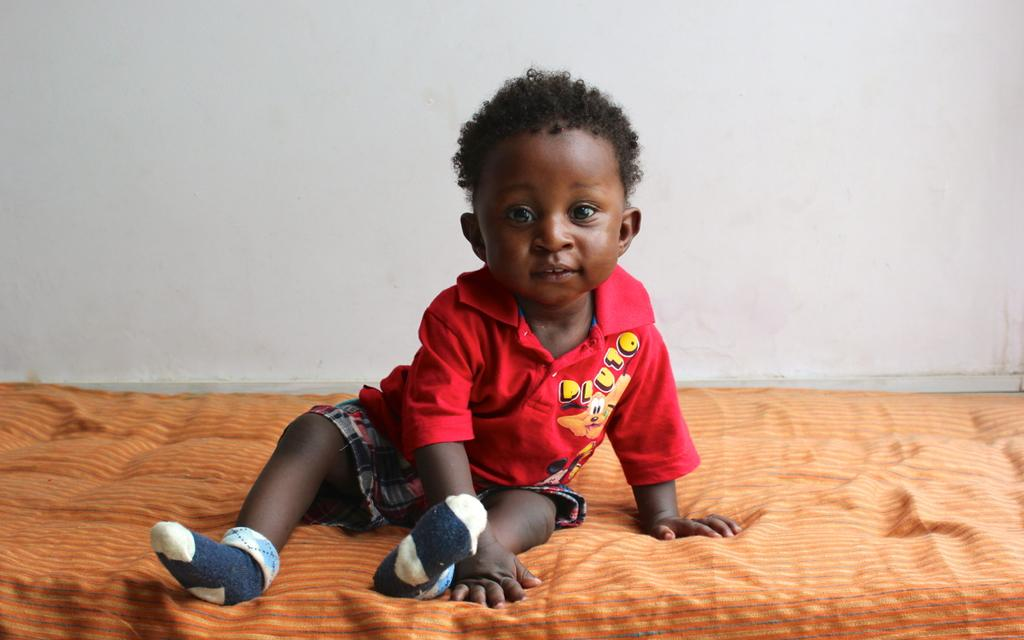What is the main subject of the image? There is a baby in the image. What is the baby sitting on? The baby is sitting on an orange color bed. What is the baby wearing on their upper body? The baby is wearing a red top. What is the baby wearing on their lower body? The baby is wearing multi-color shorts. What color is the wall in the background? The wall is white in color. How many spiders are crawling on the baby's head in the image? There are no spiders present in the image. What type of border is visible around the baby's shorts? There is no border visible around the baby's shorts; they are multi-color shorts. 